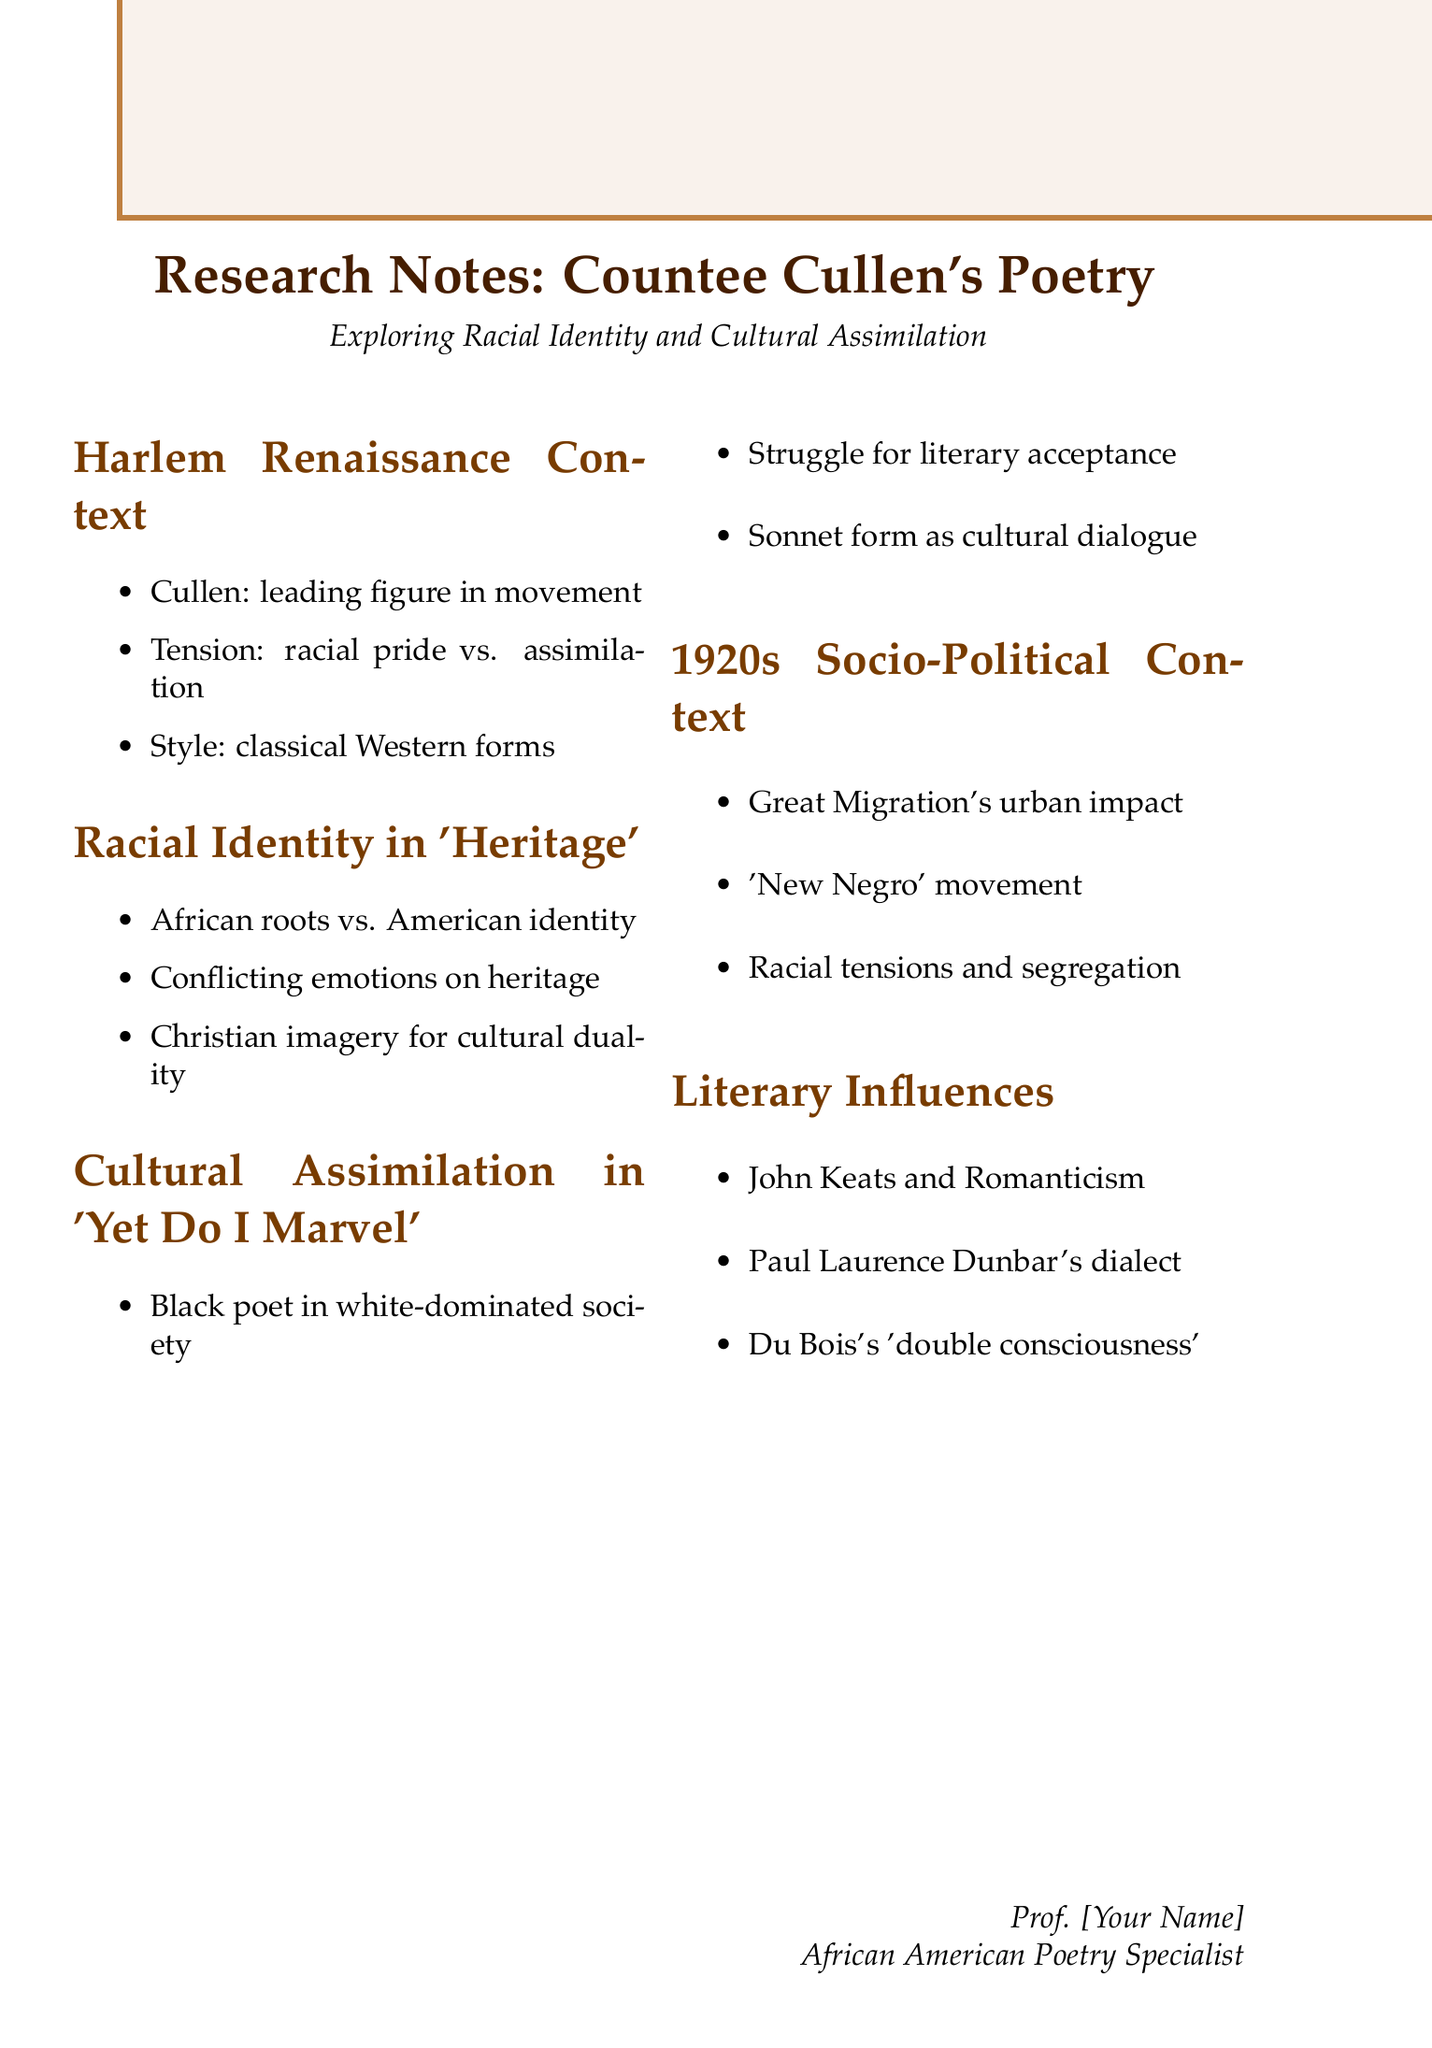What is the title of the document? The title of the document is provided at the beginning of the document under "Research Notes."
Answer: Research Notes: Countee Cullen's Poetry Who is mentioned as a leading figure in the Harlem Renaissance? This information is included under the key points of the Harlem Renaissance context section in the document.
Answer: Cullen What is the main theme explored in the poem "Heritage"? The analysis under the section about racial identity in "Heritage" points out a key theme.
Answer: African roots and American identity What traditional form does Cullen use in "Yet Do I Marvel"? This detail is found under the themes section of "Cultural Assimilation in 'Yet Do I Marvel'."
Answer: Sonnet form What socio-political factor significantly impacted African American culture in the 1920s? One of the factors listed within the socio-political context section addresses a major event affecting culture.
Answer: Great Migration Which literary influence is associated with 'double consciousness'? This information can be found under the "Literary Influences" section, attributing it to a particular author.
Answer: W.E.B. Du Bois What emotion is expressed toward African heritage in "Heritage"? The conflicting emotions towards heritage are discussed in the analysis of the poem.
Answer: Conflicting emotions What year is the socio-political context focused on? The document explicitly states the decade focused on within the socio-political context section.
Answer: 1920s 